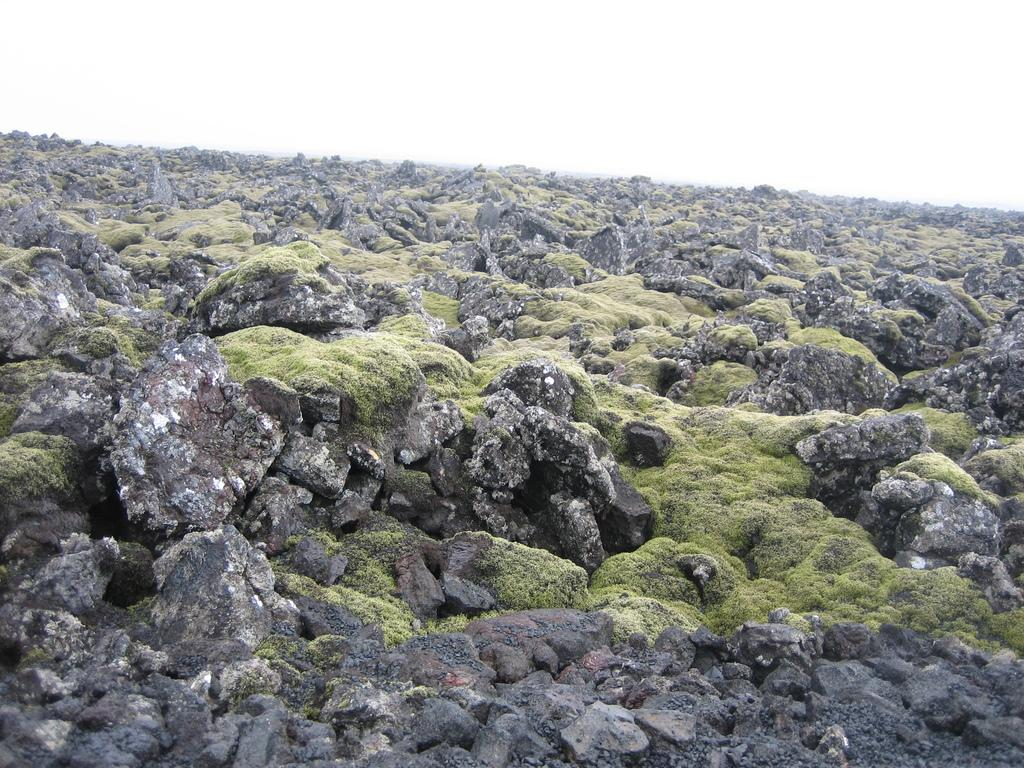What type of natural elements can be seen in the image? There are rocks with algae and sand visible in the image. What is visible at the top of the image? The sky is visible at the top of the image. How many pets are visible in the image? There are no pets present in the image. What type of button can be seen in the image? There is no button present in the image. 